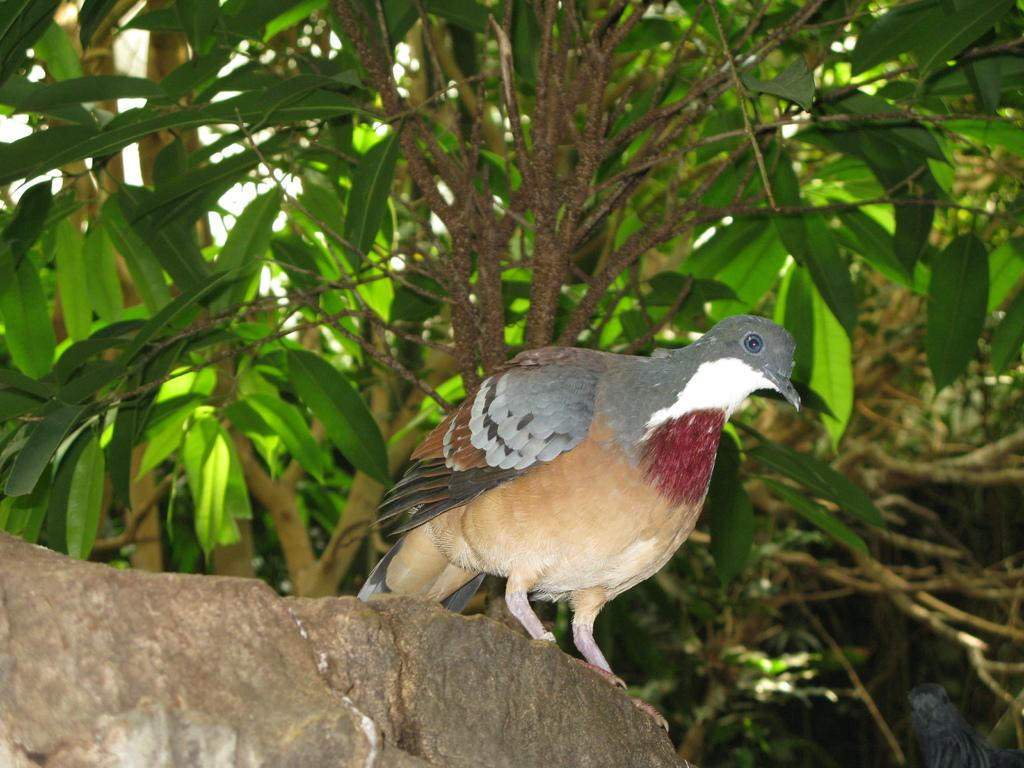What is the main subject of the image? There is a bird on a rock in the image. Are there any other birds in the image? Yes, there is another bird beside the rock in the image. What can be seen in the background of the image? There are trees in the background of the image. What type of celery is the beggar holding in the image? There is no beggar or celery present in the image; it features two birds and trees in the background. Can you hear the drum being played in the image? There is no drum or sound present in the image; it is a still image of birds and trees. 